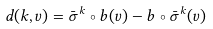Convert formula to latex. <formula><loc_0><loc_0><loc_500><loc_500>d ( k , v ) = \bar { \sigma } ^ { k } \circ b ( v ) - b \circ \bar { \sigma } ^ { k } ( v )</formula> 